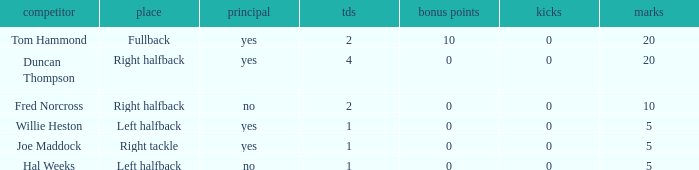How many touchdowns are there when there were 0 extra points and Hal Weeks had left halfback? 1.0. 